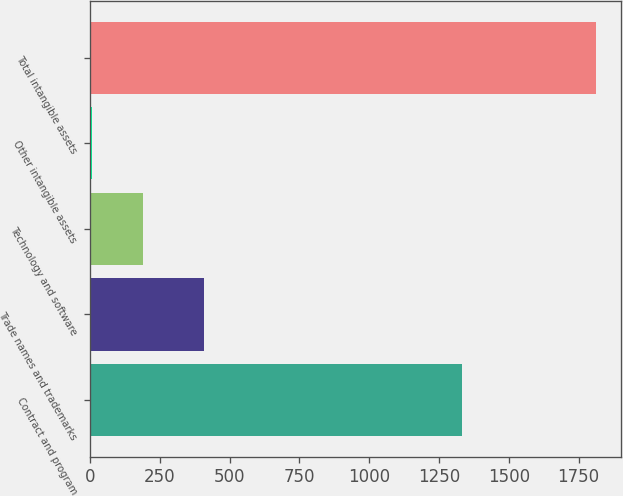<chart> <loc_0><loc_0><loc_500><loc_500><bar_chart><fcel>Contract and program<fcel>Trade names and trademarks<fcel>Technology and software<fcel>Other intangible assets<fcel>Total intangible assets<nl><fcel>1333<fcel>407<fcel>188.5<fcel>8<fcel>1813<nl></chart> 